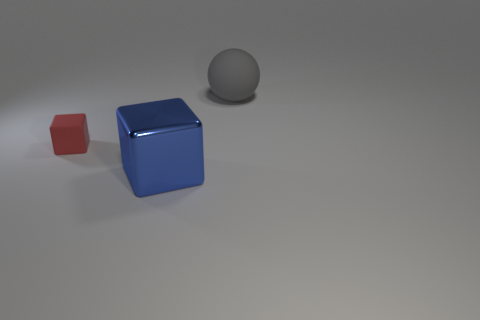Add 2 matte cylinders. How many objects exist? 5 Subtract all blocks. How many objects are left? 1 Subtract 0 blue balls. How many objects are left? 3 Subtract all gray things. Subtract all large spheres. How many objects are left? 1 Add 3 small objects. How many small objects are left? 4 Add 3 big shiny things. How many big shiny things exist? 4 